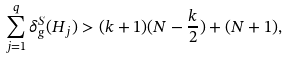Convert formula to latex. <formula><loc_0><loc_0><loc_500><loc_500>\sum _ { j = 1 } ^ { q } \delta _ { g } ^ { S } ( H _ { j } ) > ( k + 1 ) ( N - \frac { k } { 2 } ) + ( N + 1 ) ,</formula> 